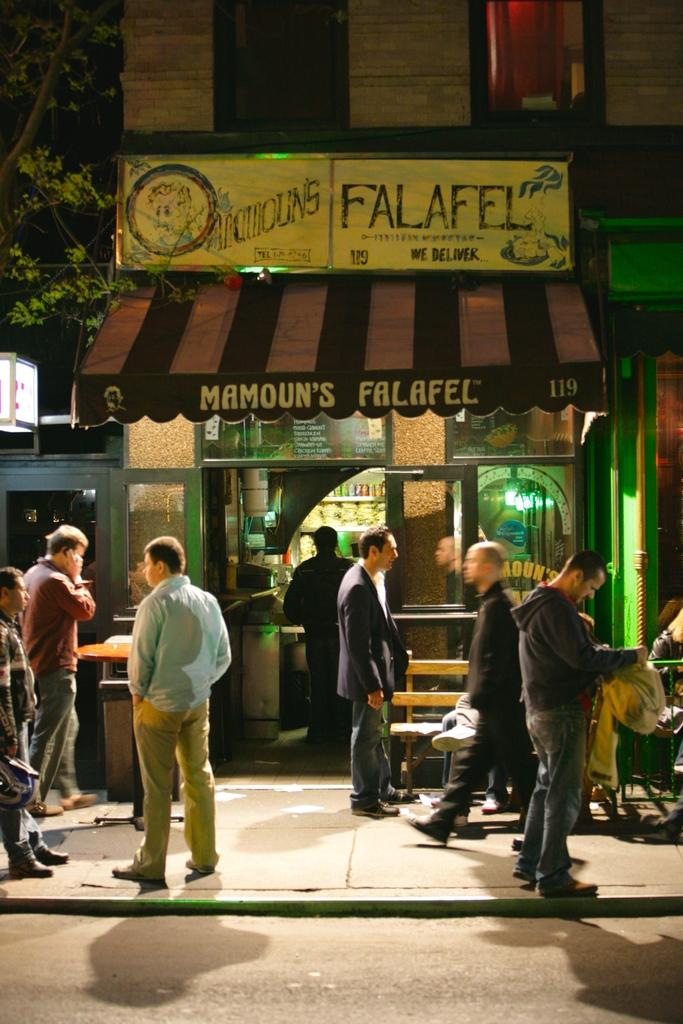Who or what can be seen in the image? There are people in the image. What type of establishment is visible in the image? There is a shop in the image. What type of seating is available in the image? There is a bench in the image. What type of structure is present in the image? There is a building in the image. What features can be observed on the building? The building has windows and lights. What type of vegetation is present in the image? There is a tree in the image. What type of signage is visible in the image? There is a board with text in the image. What type of canvas is being used to paint the war scene in the image? There is no canvas or war scene present in the image. What type of key is being used to unlock the door of the shop in the image? There is no key visible in the image, and it is not mentioned that the shop is locked. 